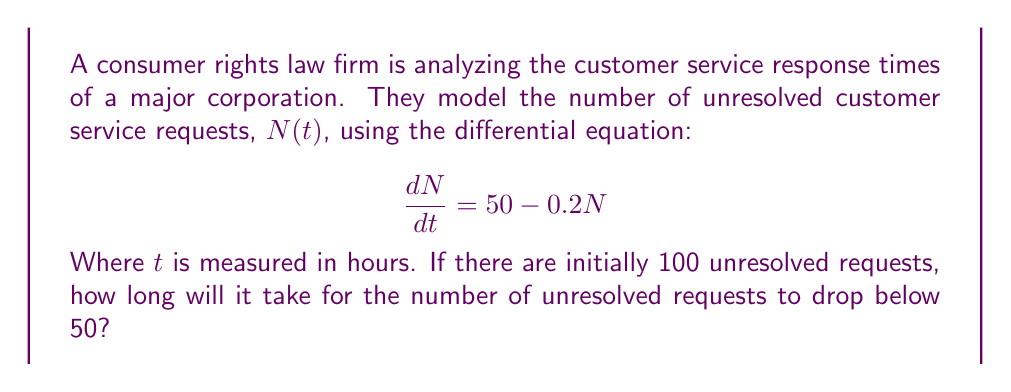Show me your answer to this math problem. Let's approach this step-by-step:

1) The given differential equation is:

   $$\frac{dN}{dt} = 50 - 0.2N$$

2) This is a first-order linear differential equation. The general solution is:

   $$N(t) = 250 + Ce^{-0.2t}$$

   Where $C$ is a constant determined by the initial condition.

3) Given the initial condition $N(0) = 100$, we can find $C$:

   $$100 = 250 + C$$
   $$C = -150$$

4) So, the particular solution is:

   $$N(t) = 250 - 150e^{-0.2t}$$

5) We want to find when $N(t) < 50$. Let's set up the inequality:

   $$250 - 150e^{-0.2t} < 50$$

6) Solving for $t$:

   $$-150e^{-0.2t} < -200$$
   $$e^{-0.2t} > \frac{4}{3}$$
   $$-0.2t > \ln(\frac{4}{3})$$
   $$t < -5\ln(\frac{4}{3})$$

7) Calculating the value:

   $$t \approx 14.38 \text{ hours}$$
Answer: 14.38 hours 